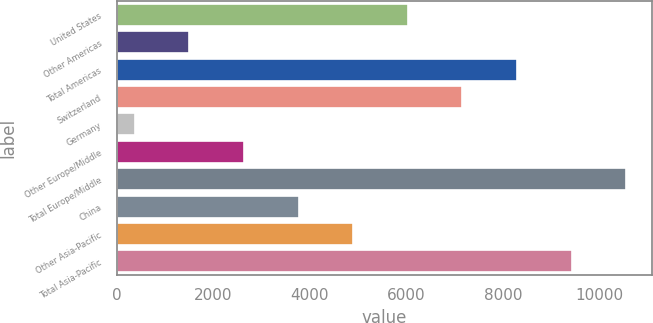<chart> <loc_0><loc_0><loc_500><loc_500><bar_chart><fcel>United States<fcel>Other Americas<fcel>Total Americas<fcel>Switzerland<fcel>Germany<fcel>Other Europe/Middle<fcel>Total Europe/Middle<fcel>China<fcel>Other Asia-Pacific<fcel>Total Asia-Pacific<nl><fcel>6027<fcel>1503.8<fcel>8288.6<fcel>7157.8<fcel>373<fcel>2634.6<fcel>10550.2<fcel>3765.4<fcel>4896.2<fcel>9419.4<nl></chart> 